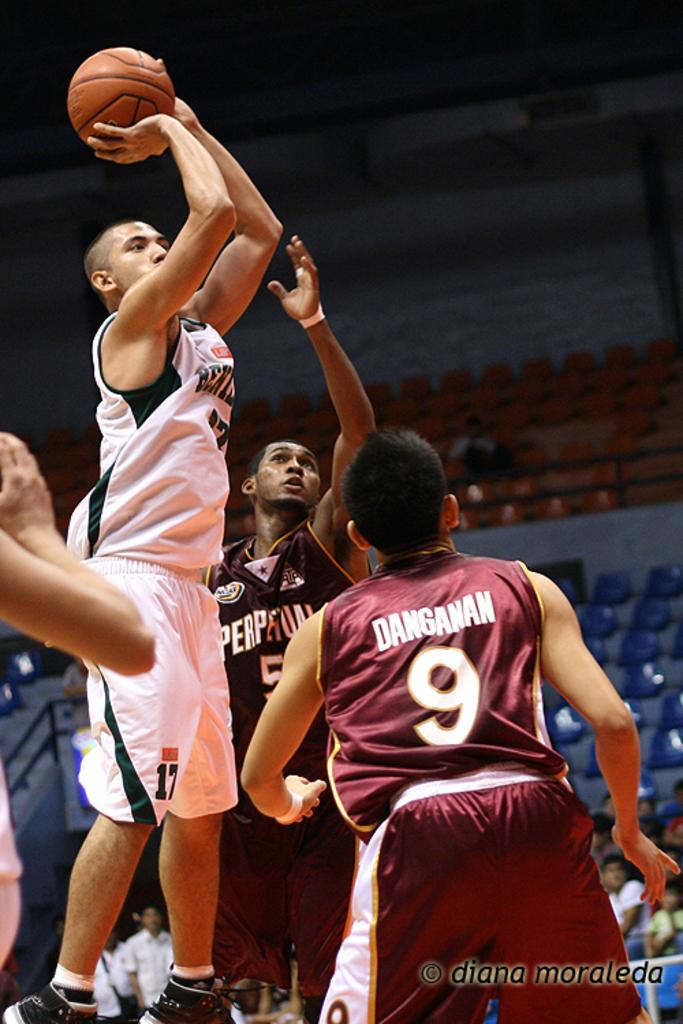<image>
Offer a succinct explanation of the picture presented. Basketball player shooting over player number 9 named Danganan. 